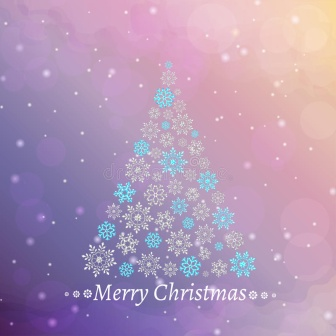Imagine if the snowflakes in this image were alive. What kind of story could unfold? Once upon a time, in a magical winter land, the snowflakes were alive and had their own personalities. Each snowflake was unique, with its own story to tell. The largest snowflakes at the base of the tree were the oldest, wise and full of ancient tales of winters past. The smaller snowflakes near the top were the youngest, full of curiosity and excitement. Every night, they would come to life, dancing in the moonlit sky, sharing their stories and dreams with one another. Their favorite tale was of the time they came together to form the magnificent Christmas tree, bringing joy and wonder to all who saw them. As they danced, they sang a melodious song, spreading the spirit of Christmas far and wide, making every heart they touched feel the magic of the season. 